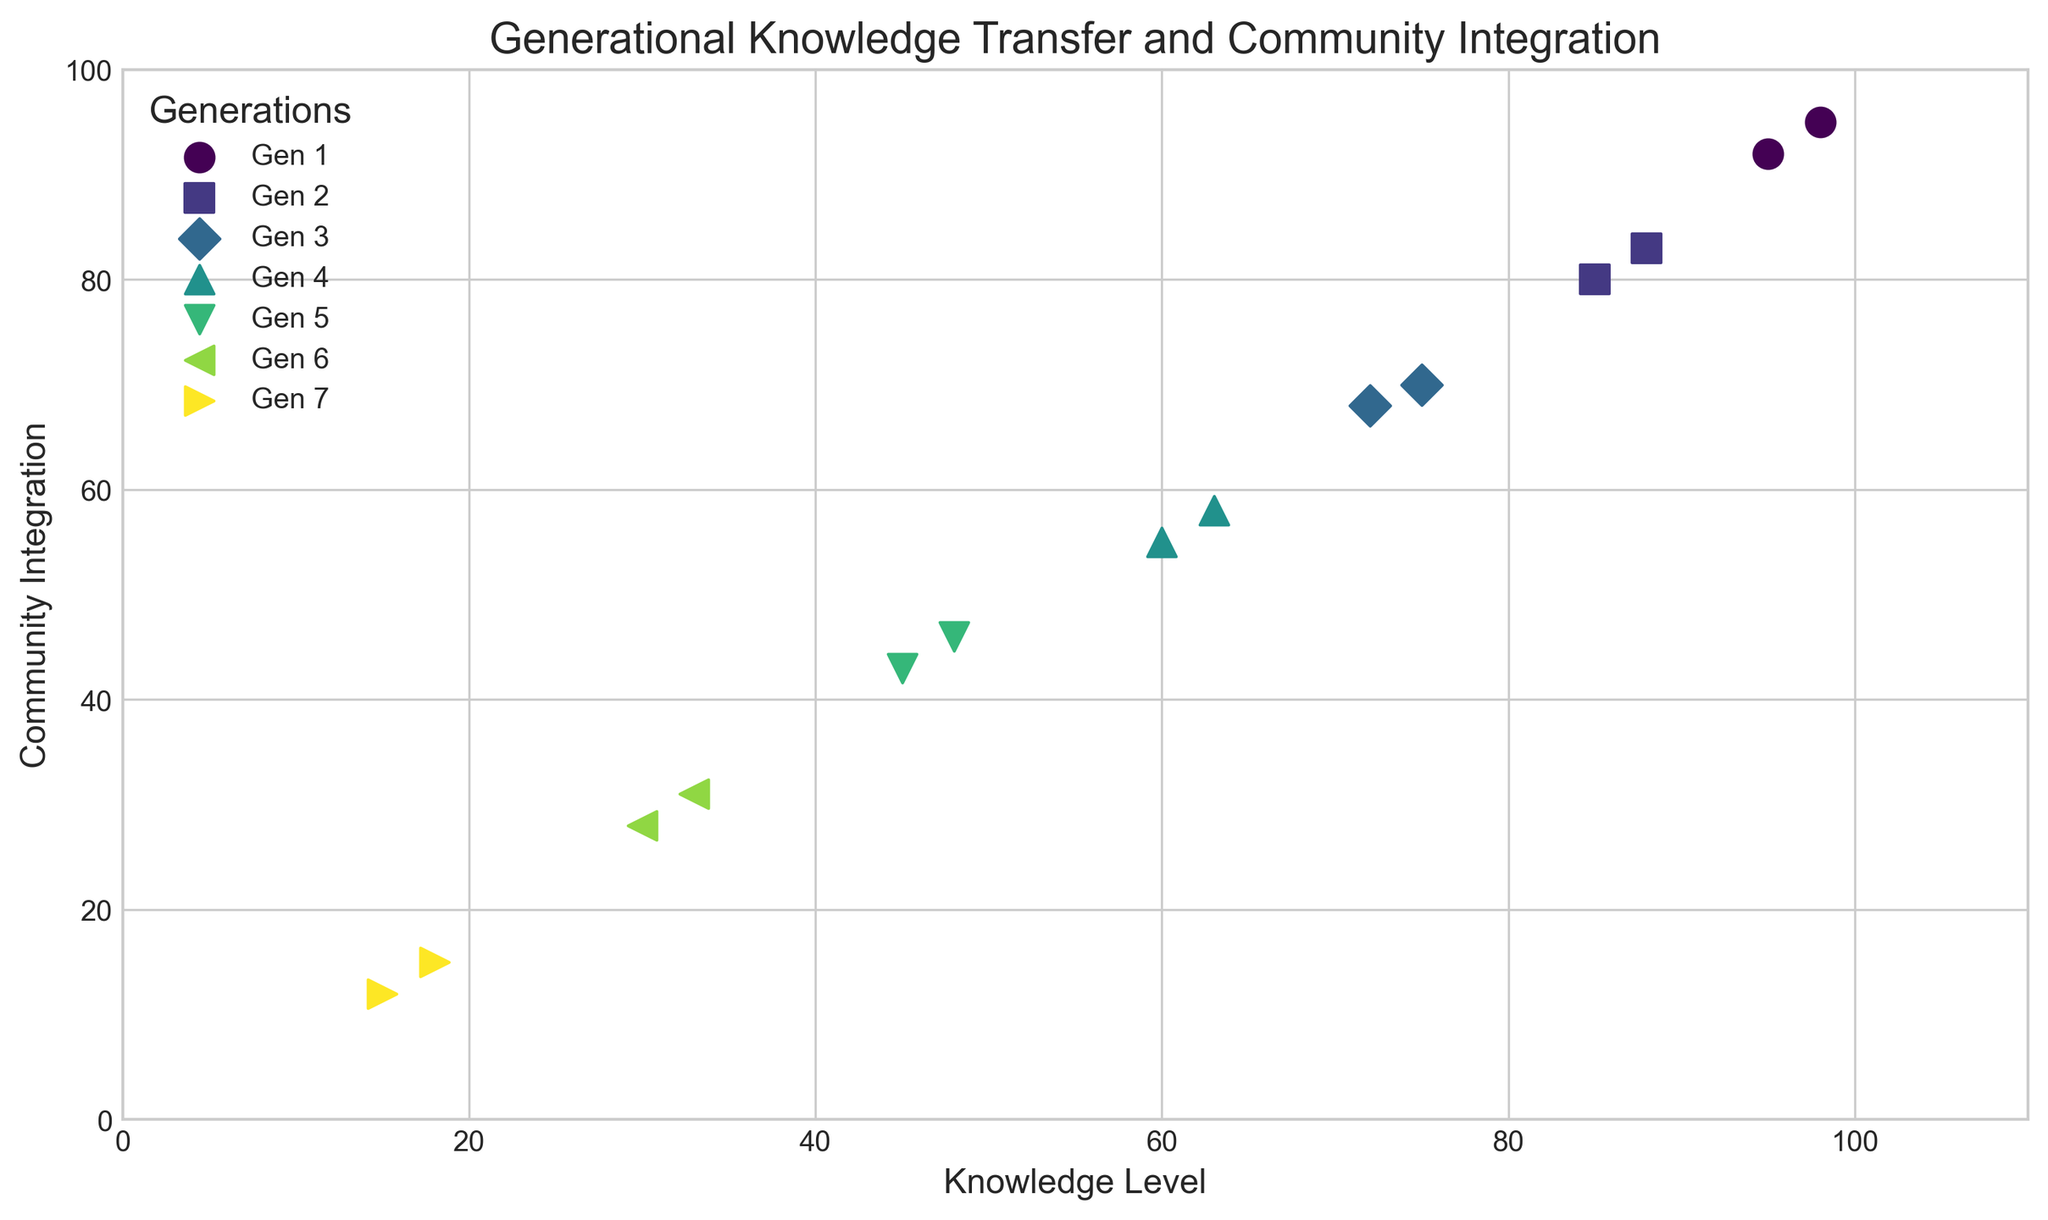What is the trend of Knowledge Level across generations? The scatter plot shows that Knowledge Level decreases progressively with each successive generation from 1 to 7. This is evident as the points for each generation are plotted lower compared to the previous one.
Answer: Knowledge Level decreases across generations Which generation has the highest level of Community Integration? By observing the scatter plot, we can see that Generation 1 has the highest level of Community Integration with values around 95 and 92 indicated by separate points.
Answer: Generation 1 Compare the Knowledge Levels between Generation 4 and Generation 6. In Generation 4, Knowledge Levels are 60 and 63. In Generation 6, they are 30 and 33. Comparing these, Generation 4 has significantly higher Knowledge Levels than Generation 6.
Answer: Generation 4 has higher Knowledge Levels What is the average Community Integration for Generation 3? For Generation 3, the Community Integration values are 70 and 68. The average is calculated as (70 + 68) / 2 = 69.
Answer: 69 Which Generation shows the lowest levels of both Knowledge Level and Community Integration? By examining the scatter plot, we see that Generation 7 has the lowest Knowledge Level (15 and 18) and Community Integration (12 and 15).
Answer: Generation 7 From Generations 2 to 4, how does Community Integration change? Generation 2 has Community Integration values of 80 and 83, Generation 3 has values of 70 and 68, and Generation 4 has values of 55 and 58. The trend shows a decreasing Community Integration from Generation 2 to 4.
Answer: Decreasing By how much does the average Knowledge Level decrease from Generation 1 to Generation 5? For Generation 1, the Knowledge Levels are 98 and 95, averaging (98 + 95) / 2 = 96.5. For Generation 5, the Knowledge Levels are 45 and 48, averaging (45 + 48) / 2 = 46.5. The decrease is 96.5 - 46.5 = 50.
Answer: 50 Which generation's data points are plotted with triangle markers? The scatter plot uses different markers for each generation. Observing the legend, we see that Generation 3's data points are indicated with triangle markers.
Answer: Generation 3 Are there any generations where the Knowledge Level values overlap exactly? By carefully examining the Knowledge Level values for all generations, we see that none of the generations have identical Knowledge Level values; all values are distinct across generations.
Answer: No 